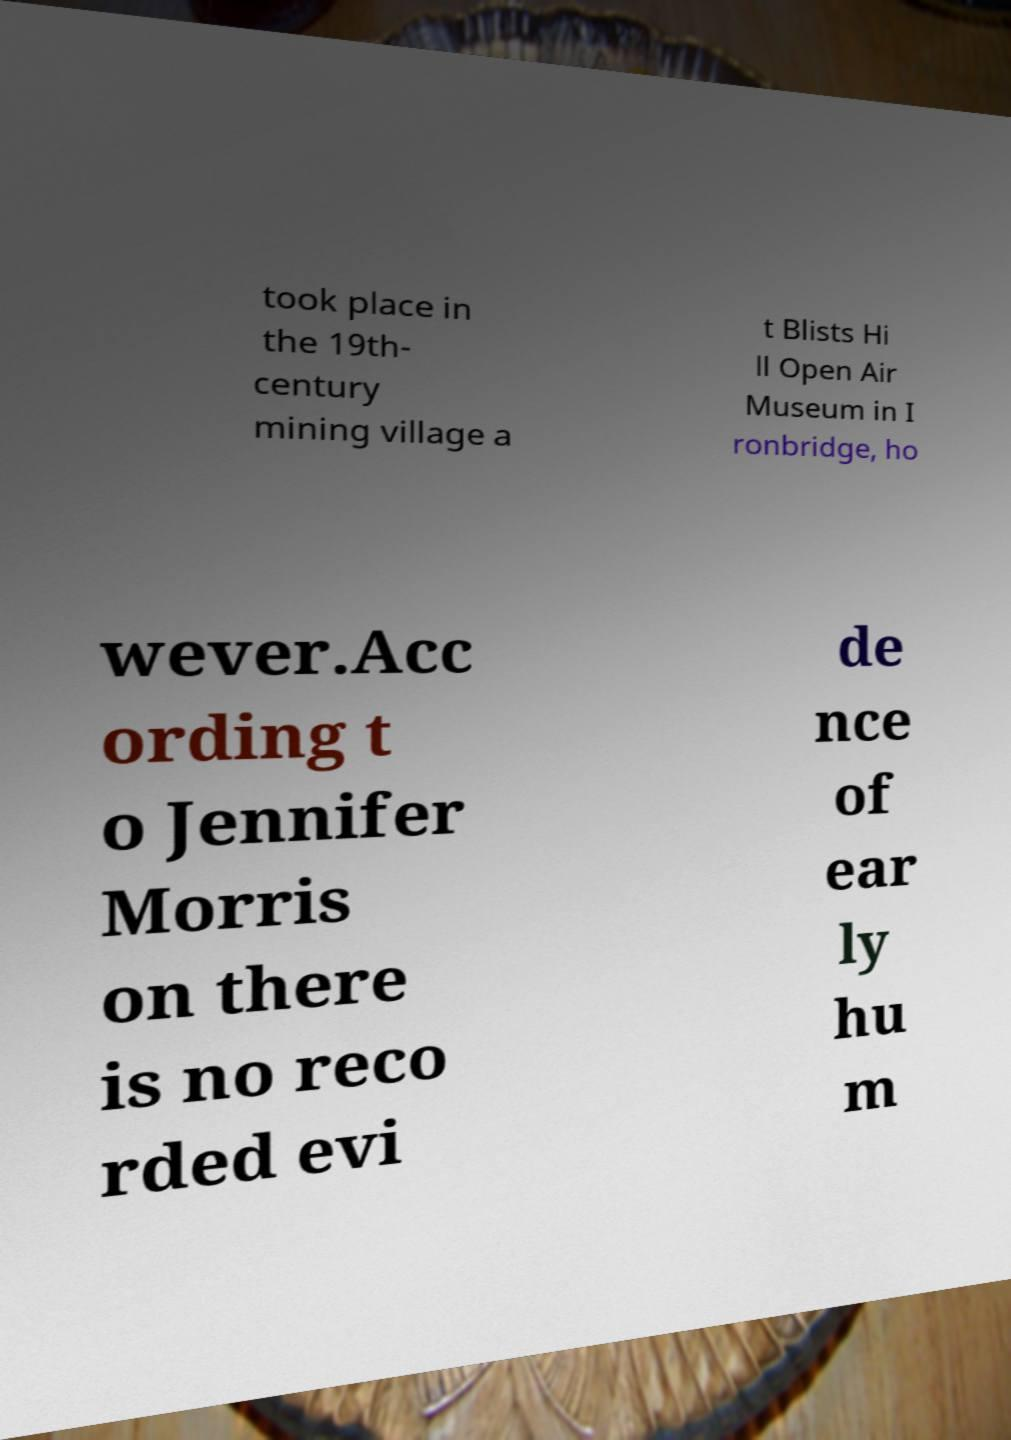Can you accurately transcribe the text from the provided image for me? took place in the 19th- century mining village a t Blists Hi ll Open Air Museum in I ronbridge, ho wever.Acc ording t o Jennifer Morris on there is no reco rded evi de nce of ear ly hu m 